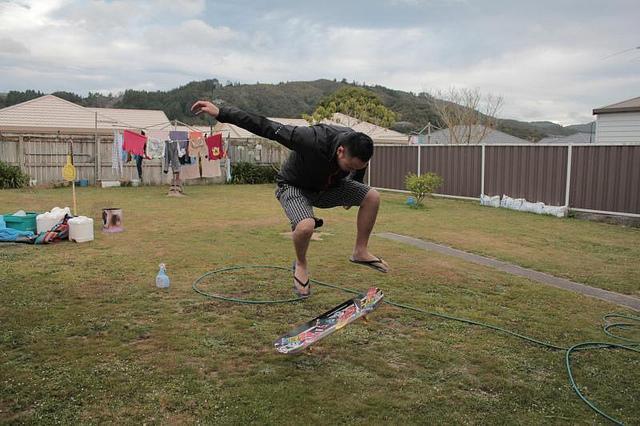How many skateboards can be seen?
Give a very brief answer. 1. How many people are in the picture?
Give a very brief answer. 1. 